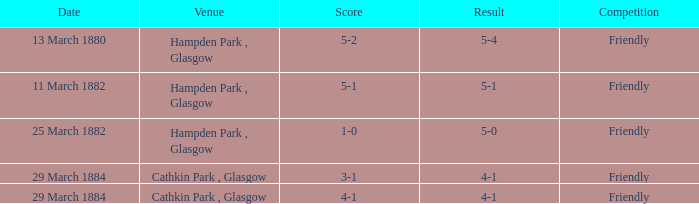Which item has a score of 5-1? 5-1. 